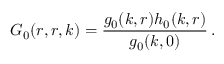Convert formula to latex. <formula><loc_0><loc_0><loc_500><loc_500>G _ { 0 } ( r , r , k ) = \frac { g _ { 0 } ( k , r ) h _ { 0 } ( k , r ) } { g _ { 0 } ( k , 0 ) } \, .</formula> 